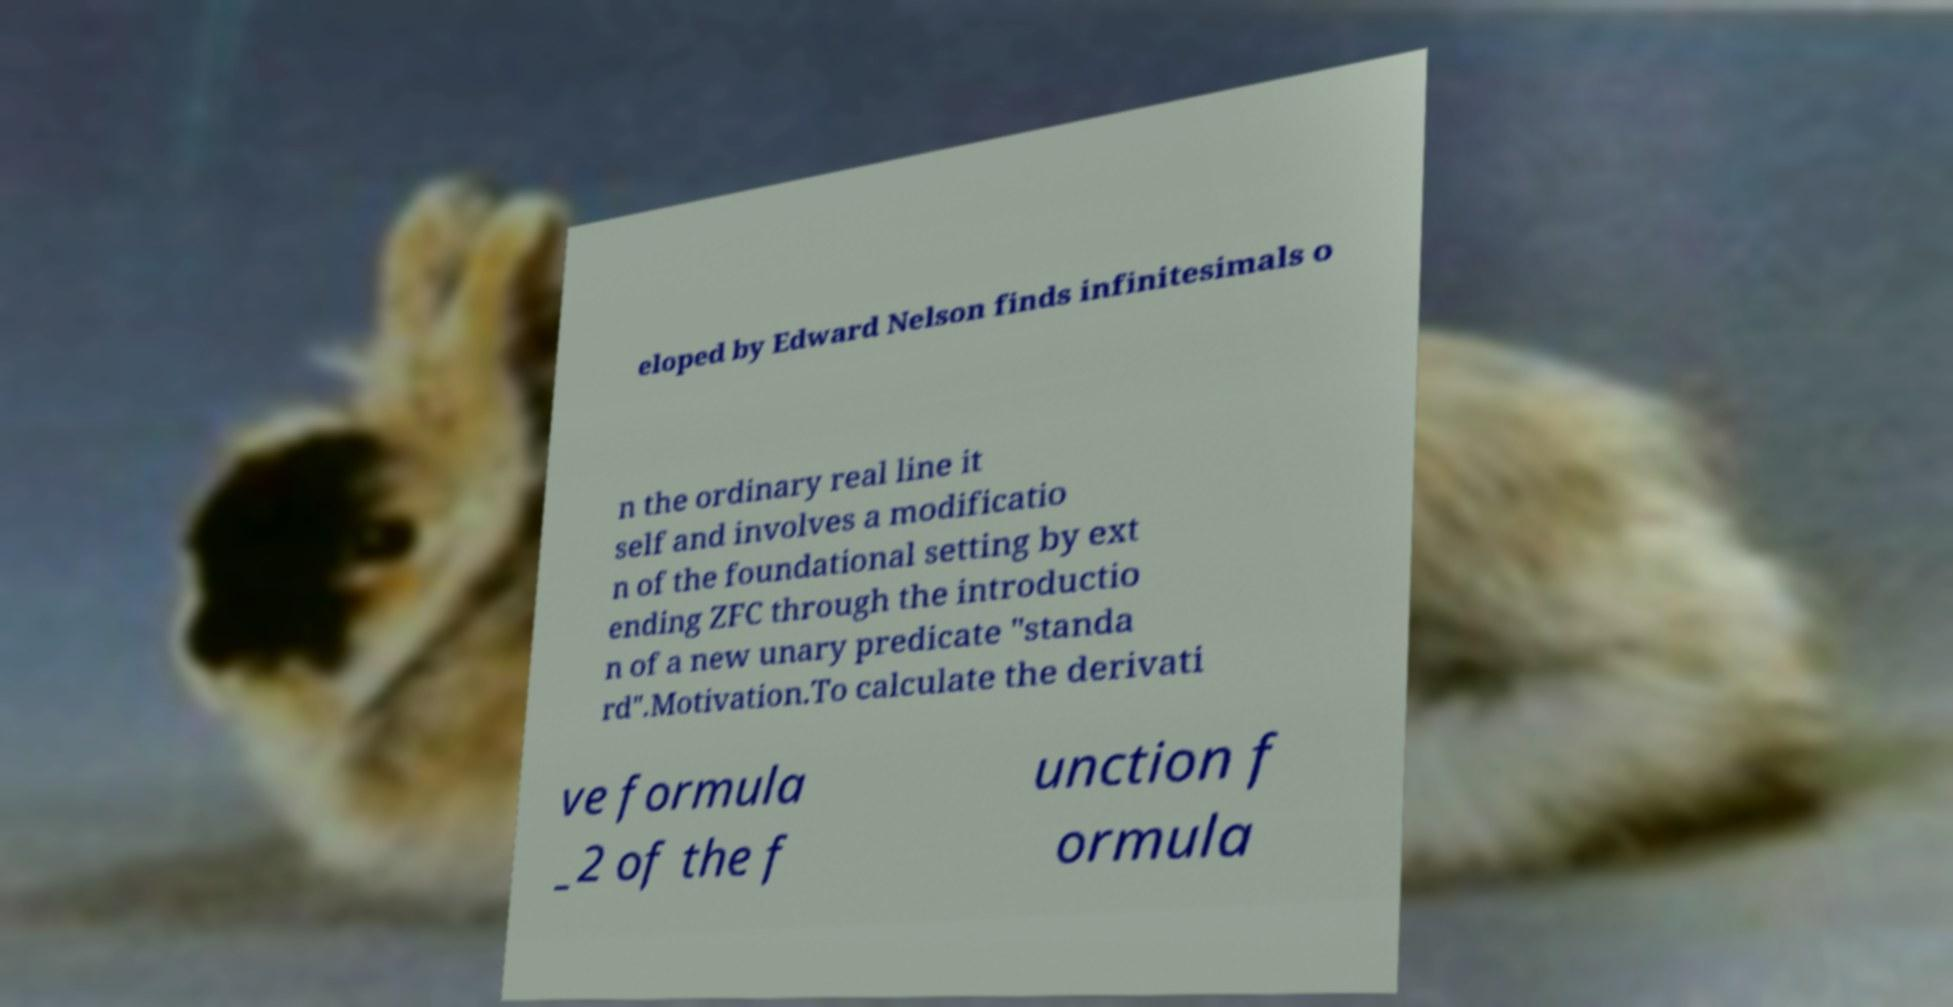Please read and relay the text visible in this image. What does it say? eloped by Edward Nelson finds infinitesimals o n the ordinary real line it self and involves a modificatio n of the foundational setting by ext ending ZFC through the introductio n of a new unary predicate "standa rd".Motivation.To calculate the derivati ve formula _2 of the f unction f ormula 